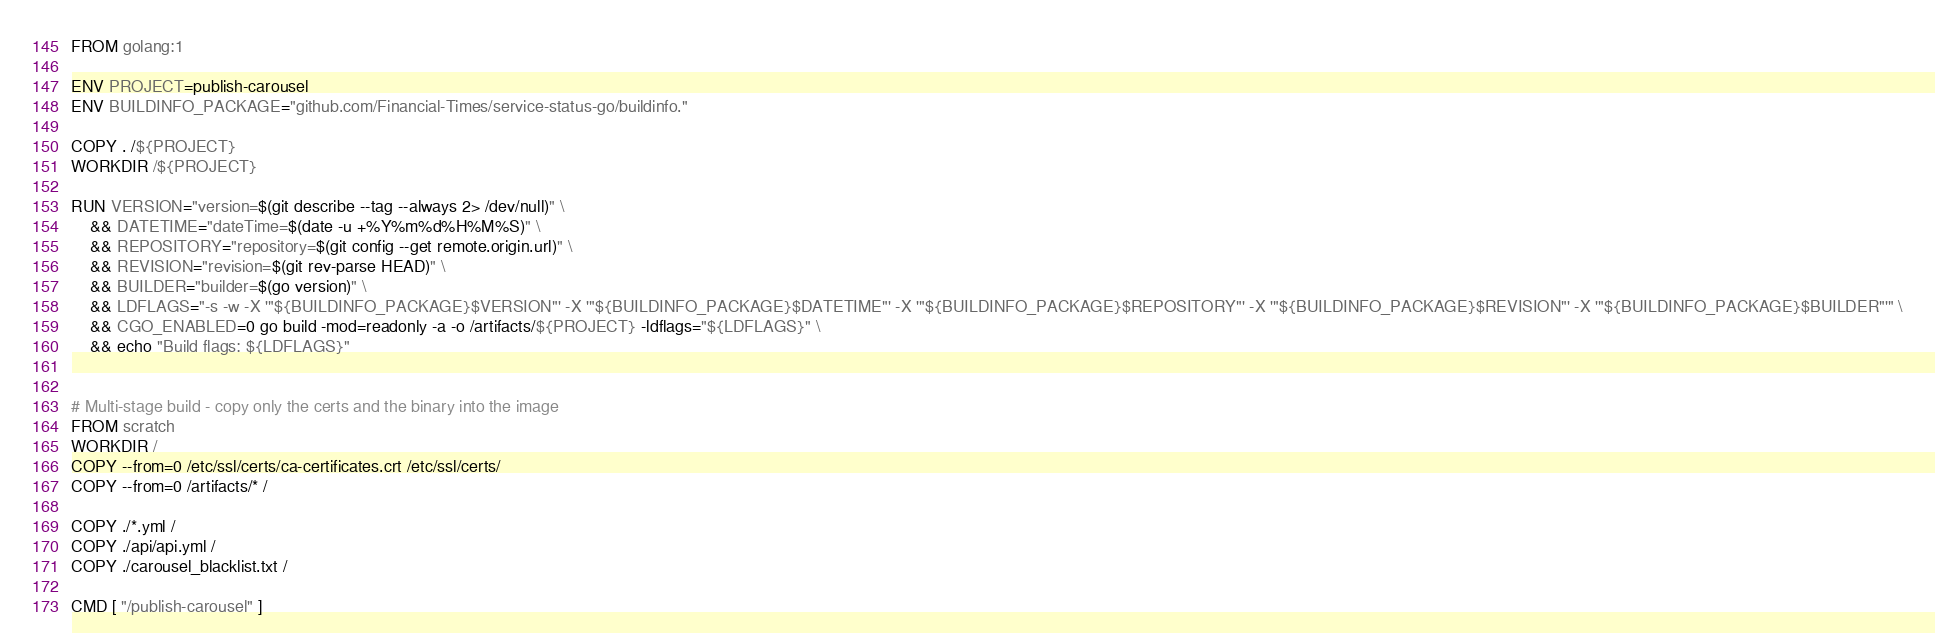Convert code to text. <code><loc_0><loc_0><loc_500><loc_500><_Dockerfile_>FROM golang:1

ENV PROJECT=publish-carousel
ENV BUILDINFO_PACKAGE="github.com/Financial-Times/service-status-go/buildinfo."

COPY . /${PROJECT}
WORKDIR /${PROJECT}

RUN VERSION="version=$(git describe --tag --always 2> /dev/null)" \
    && DATETIME="dateTime=$(date -u +%Y%m%d%H%M%S)" \
    && REPOSITORY="repository=$(git config --get remote.origin.url)" \
    && REVISION="revision=$(git rev-parse HEAD)" \
    && BUILDER="builder=$(go version)" \
    && LDFLAGS="-s -w -X '"${BUILDINFO_PACKAGE}$VERSION"' -X '"${BUILDINFO_PACKAGE}$DATETIME"' -X '"${BUILDINFO_PACKAGE}$REPOSITORY"' -X '"${BUILDINFO_PACKAGE}$REVISION"' -X '"${BUILDINFO_PACKAGE}$BUILDER"'" \
    && CGO_ENABLED=0 go build -mod=readonly -a -o /artifacts/${PROJECT} -ldflags="${LDFLAGS}" \
    && echo "Build flags: ${LDFLAGS}"


# Multi-stage build - copy only the certs and the binary into the image
FROM scratch
WORKDIR /
COPY --from=0 /etc/ssl/certs/ca-certificates.crt /etc/ssl/certs/
COPY --from=0 /artifacts/* /

COPY ./*.yml / 
COPY ./api/api.yml / 
COPY ./carousel_blacklist.txt / 

CMD [ "/publish-carousel" ]
</code> 